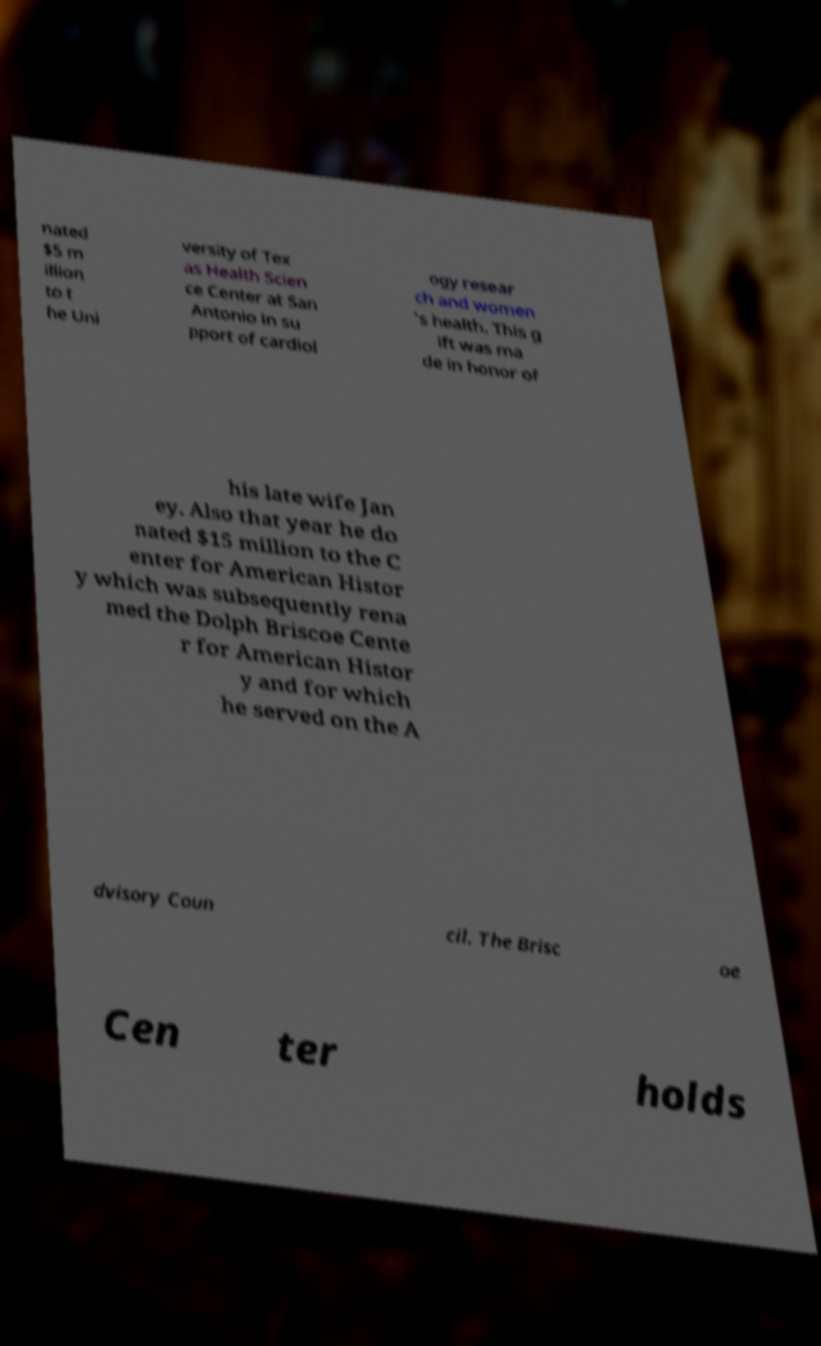Could you extract and type out the text from this image? nated $5 m illion to t he Uni versity of Tex as Health Scien ce Center at San Antonio in su pport of cardiol ogy resear ch and women 's health. This g ift was ma de in honor of his late wife Jan ey. Also that year he do nated $15 million to the C enter for American Histor y which was subsequently rena med the Dolph Briscoe Cente r for American Histor y and for which he served on the A dvisory Coun cil. The Brisc oe Cen ter holds 